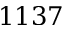<formula> <loc_0><loc_0><loc_500><loc_500>1 1 3 7</formula> 